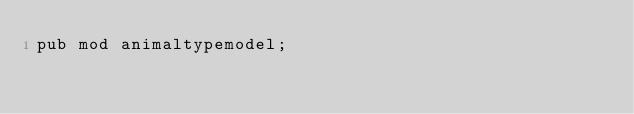<code> <loc_0><loc_0><loc_500><loc_500><_Rust_>pub mod animaltypemodel;
</code> 